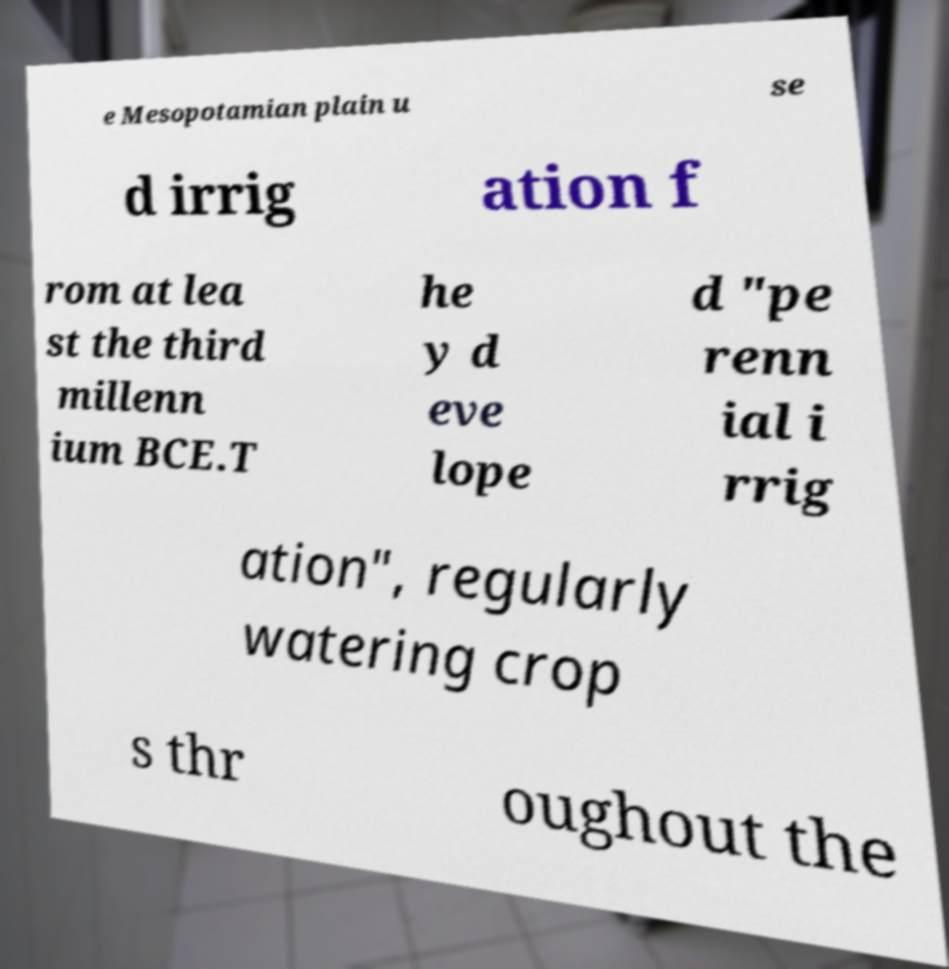Can you accurately transcribe the text from the provided image for me? e Mesopotamian plain u se d irrig ation f rom at lea st the third millenn ium BCE.T he y d eve lope d "pe renn ial i rrig ation", regularly watering crop s thr oughout the 